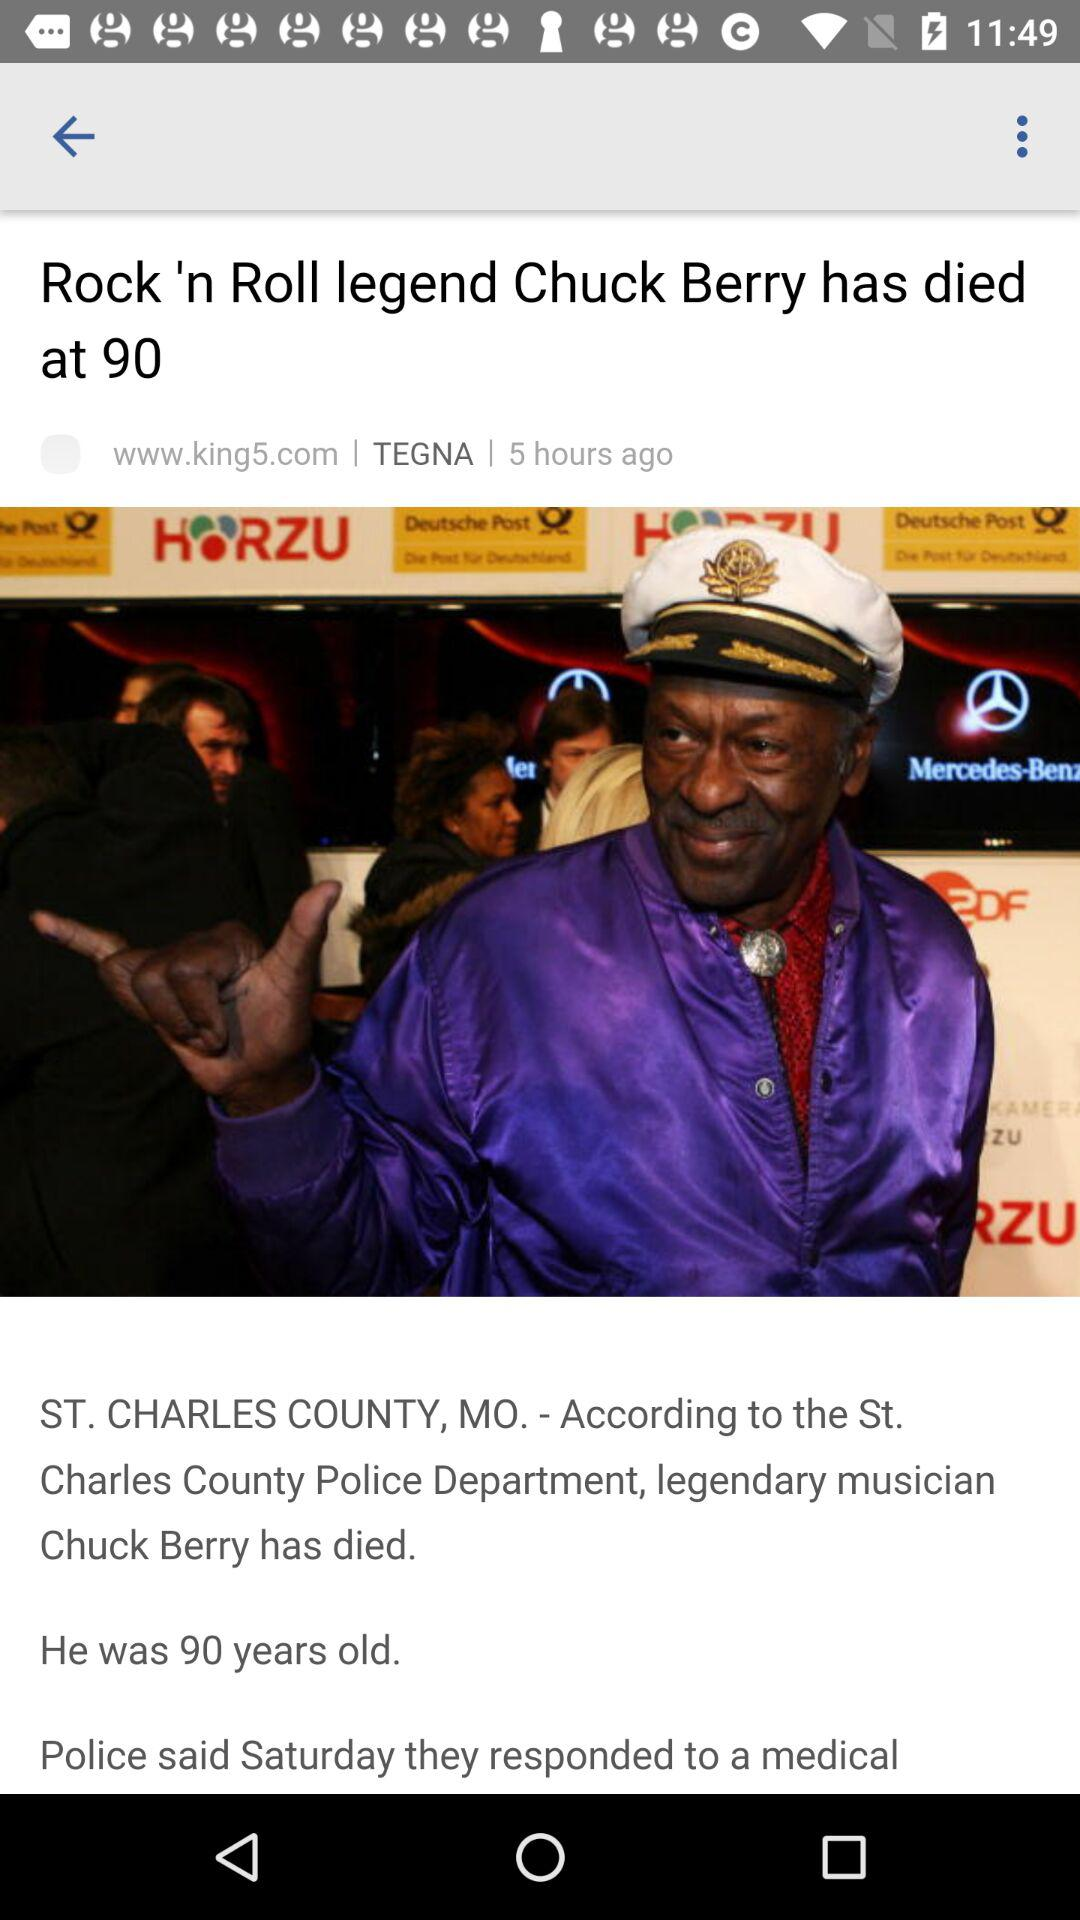How old was he? He was 90 years old. 